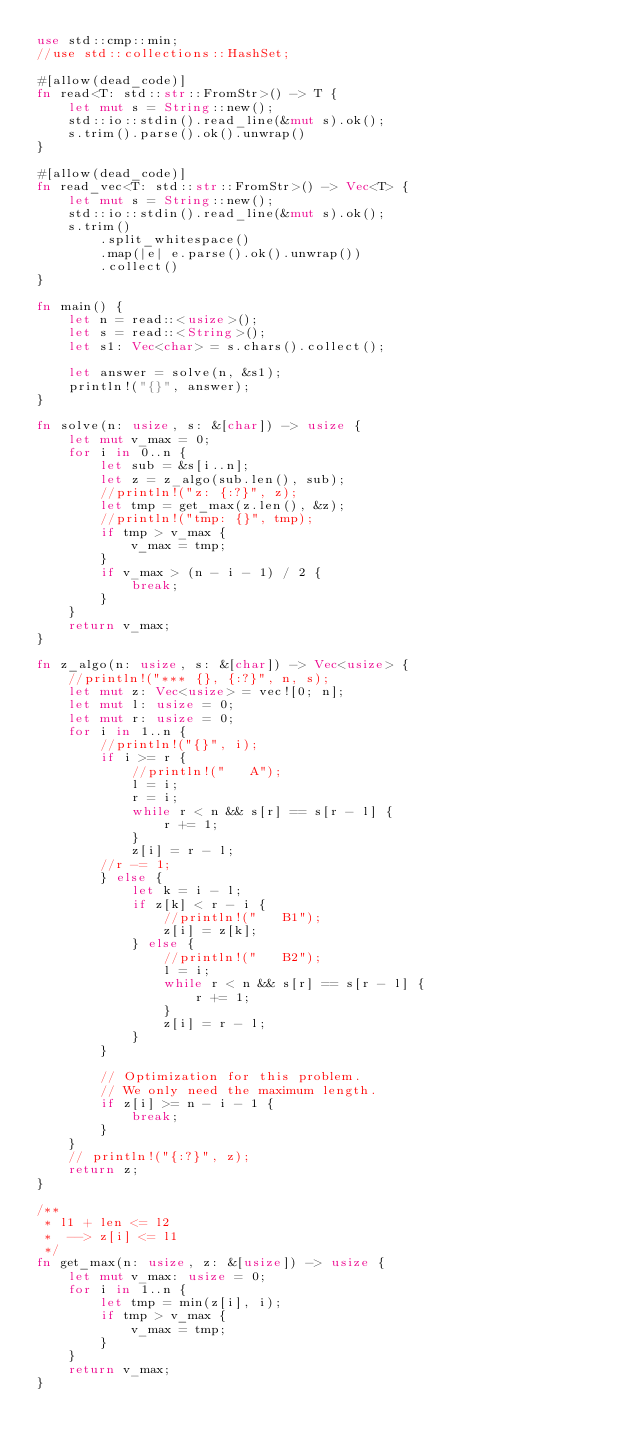<code> <loc_0><loc_0><loc_500><loc_500><_Rust_>use std::cmp::min;
//use std::collections::HashSet;

#[allow(dead_code)]
fn read<T: std::str::FromStr>() -> T {
    let mut s = String::new();
    std::io::stdin().read_line(&mut s).ok();
    s.trim().parse().ok().unwrap()
}

#[allow(dead_code)]
fn read_vec<T: std::str::FromStr>() -> Vec<T> {
    let mut s = String::new();
    std::io::stdin().read_line(&mut s).ok();
    s.trim()
        .split_whitespace()
        .map(|e| e.parse().ok().unwrap())
        .collect()
}

fn main() {
    let n = read::<usize>();
    let s = read::<String>();
    let s1: Vec<char> = s.chars().collect();

    let answer = solve(n, &s1);
    println!("{}", answer);
}

fn solve(n: usize, s: &[char]) -> usize {
    let mut v_max = 0;
    for i in 0..n {
        let sub = &s[i..n];
        let z = z_algo(sub.len(), sub);
        //println!("z: {:?}", z);
        let tmp = get_max(z.len(), &z);
        //println!("tmp: {}", tmp);
        if tmp > v_max {
            v_max = tmp;
        }
        if v_max > (n - i - 1) / 2 {
            break;
        }
    }
    return v_max;
}

fn z_algo(n: usize, s: &[char]) -> Vec<usize> {
    //println!("*** {}, {:?}", n, s);
    let mut z: Vec<usize> = vec![0; n];
    let mut l: usize = 0;
    let mut r: usize = 0;
    for i in 1..n {
        //println!("{}", i);
        if i >= r {
            //println!("   A");
            l = i;
            r = i;
            while r < n && s[r] == s[r - l] {
                r += 1;
            }
            z[i] = r - l;
        //r -= 1;
        } else {
            let k = i - l;
            if z[k] < r - i {
                //println!("   B1");
                z[i] = z[k];
            } else {
                //println!("   B2");
                l = i;
                while r < n && s[r] == s[r - l] {
                    r += 1;
                }
                z[i] = r - l;
            }
        }

        // Optimization for this problem.
        // We only need the maximum length.
        if z[i] >= n - i - 1 {
            break;
        }
    }
    // println!("{:?}", z);
    return z;
}

/**
 * l1 + len <= l2
 *  --> z[i] <= l1
 */
fn get_max(n: usize, z: &[usize]) -> usize {
    let mut v_max: usize = 0;
    for i in 1..n {
        let tmp = min(z[i], i);
        if tmp > v_max {
            v_max = tmp;
        }
    }
    return v_max;
}
</code> 